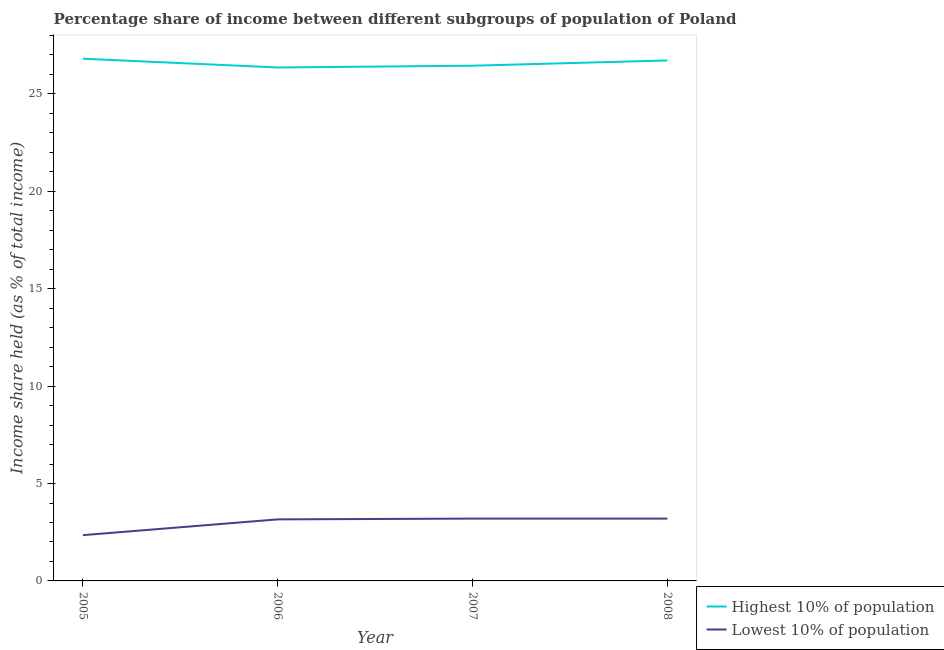Is the number of lines equal to the number of legend labels?
Make the answer very short. Yes. Across all years, what is the maximum income share held by lowest 10% of the population?
Your answer should be compact. 3.2. Across all years, what is the minimum income share held by highest 10% of the population?
Make the answer very short. 26.36. In which year was the income share held by highest 10% of the population maximum?
Keep it short and to the point. 2005. In which year was the income share held by highest 10% of the population minimum?
Your answer should be compact. 2006. What is the total income share held by lowest 10% of the population in the graph?
Give a very brief answer. 11.91. What is the difference between the income share held by lowest 10% of the population in 2006 and that in 2008?
Offer a terse response. -0.04. What is the difference between the income share held by lowest 10% of the population in 2005 and the income share held by highest 10% of the population in 2006?
Ensure brevity in your answer.  -24.01. What is the average income share held by highest 10% of the population per year?
Make the answer very short. 26.59. In the year 2006, what is the difference between the income share held by lowest 10% of the population and income share held by highest 10% of the population?
Offer a terse response. -23.2. In how many years, is the income share held by lowest 10% of the population greater than 15 %?
Offer a very short reply. 0. What is the ratio of the income share held by highest 10% of the population in 2005 to that in 2008?
Provide a short and direct response. 1. Is the difference between the income share held by lowest 10% of the population in 2005 and 2007 greater than the difference between the income share held by highest 10% of the population in 2005 and 2007?
Your answer should be very brief. No. What is the difference between the highest and the second highest income share held by lowest 10% of the population?
Offer a very short reply. 0. What is the difference between the highest and the lowest income share held by lowest 10% of the population?
Ensure brevity in your answer.  0.85. Does the income share held by lowest 10% of the population monotonically increase over the years?
Provide a succinct answer. No. How many years are there in the graph?
Provide a short and direct response. 4. Are the values on the major ticks of Y-axis written in scientific E-notation?
Offer a very short reply. No. How many legend labels are there?
Offer a terse response. 2. What is the title of the graph?
Offer a very short reply. Percentage share of income between different subgroups of population of Poland. What is the label or title of the X-axis?
Ensure brevity in your answer.  Year. What is the label or title of the Y-axis?
Provide a succinct answer. Income share held (as % of total income). What is the Income share held (as % of total income) of Highest 10% of population in 2005?
Your response must be concise. 26.81. What is the Income share held (as % of total income) of Lowest 10% of population in 2005?
Offer a very short reply. 2.35. What is the Income share held (as % of total income) in Highest 10% of population in 2006?
Make the answer very short. 26.36. What is the Income share held (as % of total income) in Lowest 10% of population in 2006?
Your answer should be very brief. 3.16. What is the Income share held (as % of total income) in Highest 10% of population in 2007?
Make the answer very short. 26.45. What is the Income share held (as % of total income) of Highest 10% of population in 2008?
Make the answer very short. 26.72. What is the Income share held (as % of total income) in Lowest 10% of population in 2008?
Your answer should be very brief. 3.2. Across all years, what is the maximum Income share held (as % of total income) in Highest 10% of population?
Your answer should be very brief. 26.81. Across all years, what is the maximum Income share held (as % of total income) in Lowest 10% of population?
Your answer should be compact. 3.2. Across all years, what is the minimum Income share held (as % of total income) of Highest 10% of population?
Keep it short and to the point. 26.36. Across all years, what is the minimum Income share held (as % of total income) in Lowest 10% of population?
Your answer should be compact. 2.35. What is the total Income share held (as % of total income) in Highest 10% of population in the graph?
Offer a terse response. 106.34. What is the total Income share held (as % of total income) of Lowest 10% of population in the graph?
Your answer should be very brief. 11.91. What is the difference between the Income share held (as % of total income) in Highest 10% of population in 2005 and that in 2006?
Make the answer very short. 0.45. What is the difference between the Income share held (as % of total income) of Lowest 10% of population in 2005 and that in 2006?
Offer a very short reply. -0.81. What is the difference between the Income share held (as % of total income) of Highest 10% of population in 2005 and that in 2007?
Your answer should be very brief. 0.36. What is the difference between the Income share held (as % of total income) of Lowest 10% of population in 2005 and that in 2007?
Provide a succinct answer. -0.85. What is the difference between the Income share held (as % of total income) in Highest 10% of population in 2005 and that in 2008?
Keep it short and to the point. 0.09. What is the difference between the Income share held (as % of total income) in Lowest 10% of population in 2005 and that in 2008?
Provide a short and direct response. -0.85. What is the difference between the Income share held (as % of total income) in Highest 10% of population in 2006 and that in 2007?
Your response must be concise. -0.09. What is the difference between the Income share held (as % of total income) of Lowest 10% of population in 2006 and that in 2007?
Give a very brief answer. -0.04. What is the difference between the Income share held (as % of total income) of Highest 10% of population in 2006 and that in 2008?
Ensure brevity in your answer.  -0.36. What is the difference between the Income share held (as % of total income) of Lowest 10% of population in 2006 and that in 2008?
Provide a short and direct response. -0.04. What is the difference between the Income share held (as % of total income) of Highest 10% of population in 2007 and that in 2008?
Provide a short and direct response. -0.27. What is the difference between the Income share held (as % of total income) in Highest 10% of population in 2005 and the Income share held (as % of total income) in Lowest 10% of population in 2006?
Provide a short and direct response. 23.65. What is the difference between the Income share held (as % of total income) in Highest 10% of population in 2005 and the Income share held (as % of total income) in Lowest 10% of population in 2007?
Keep it short and to the point. 23.61. What is the difference between the Income share held (as % of total income) of Highest 10% of population in 2005 and the Income share held (as % of total income) of Lowest 10% of population in 2008?
Your answer should be very brief. 23.61. What is the difference between the Income share held (as % of total income) of Highest 10% of population in 2006 and the Income share held (as % of total income) of Lowest 10% of population in 2007?
Your answer should be compact. 23.16. What is the difference between the Income share held (as % of total income) of Highest 10% of population in 2006 and the Income share held (as % of total income) of Lowest 10% of population in 2008?
Provide a succinct answer. 23.16. What is the difference between the Income share held (as % of total income) of Highest 10% of population in 2007 and the Income share held (as % of total income) of Lowest 10% of population in 2008?
Provide a succinct answer. 23.25. What is the average Income share held (as % of total income) of Highest 10% of population per year?
Keep it short and to the point. 26.59. What is the average Income share held (as % of total income) of Lowest 10% of population per year?
Keep it short and to the point. 2.98. In the year 2005, what is the difference between the Income share held (as % of total income) of Highest 10% of population and Income share held (as % of total income) of Lowest 10% of population?
Provide a succinct answer. 24.46. In the year 2006, what is the difference between the Income share held (as % of total income) in Highest 10% of population and Income share held (as % of total income) in Lowest 10% of population?
Provide a short and direct response. 23.2. In the year 2007, what is the difference between the Income share held (as % of total income) in Highest 10% of population and Income share held (as % of total income) in Lowest 10% of population?
Provide a short and direct response. 23.25. In the year 2008, what is the difference between the Income share held (as % of total income) in Highest 10% of population and Income share held (as % of total income) in Lowest 10% of population?
Provide a short and direct response. 23.52. What is the ratio of the Income share held (as % of total income) in Highest 10% of population in 2005 to that in 2006?
Offer a terse response. 1.02. What is the ratio of the Income share held (as % of total income) of Lowest 10% of population in 2005 to that in 2006?
Give a very brief answer. 0.74. What is the ratio of the Income share held (as % of total income) in Highest 10% of population in 2005 to that in 2007?
Provide a succinct answer. 1.01. What is the ratio of the Income share held (as % of total income) of Lowest 10% of population in 2005 to that in 2007?
Give a very brief answer. 0.73. What is the ratio of the Income share held (as % of total income) in Lowest 10% of population in 2005 to that in 2008?
Keep it short and to the point. 0.73. What is the ratio of the Income share held (as % of total income) of Lowest 10% of population in 2006 to that in 2007?
Keep it short and to the point. 0.99. What is the ratio of the Income share held (as % of total income) in Highest 10% of population in 2006 to that in 2008?
Your answer should be very brief. 0.99. What is the ratio of the Income share held (as % of total income) in Lowest 10% of population in 2006 to that in 2008?
Provide a short and direct response. 0.99. What is the ratio of the Income share held (as % of total income) of Lowest 10% of population in 2007 to that in 2008?
Give a very brief answer. 1. What is the difference between the highest and the second highest Income share held (as % of total income) in Highest 10% of population?
Ensure brevity in your answer.  0.09. What is the difference between the highest and the lowest Income share held (as % of total income) in Highest 10% of population?
Offer a terse response. 0.45. What is the difference between the highest and the lowest Income share held (as % of total income) of Lowest 10% of population?
Your answer should be compact. 0.85. 